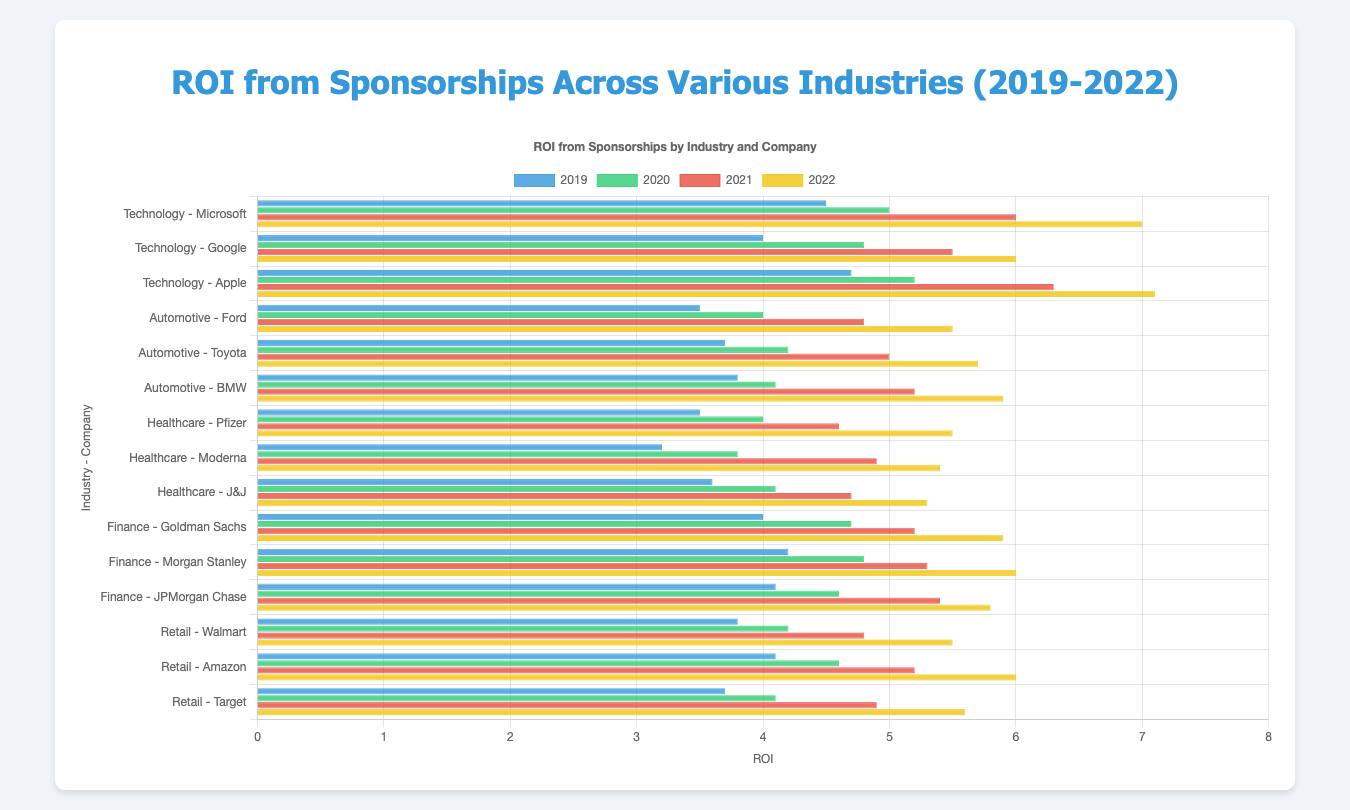What was the overall ROI trend for Technology companies from 2019 to 2022? Looking at the bars for Microsoft, Google, and Apple in the Technology sector, we observe that the heights of the bars increase consistently from 2019 to 2022 for all three companies. This indicates a general upward trend in ROI for Technology companies over these years.
Answer: Upward trend Which industry had the highest ROI in 2022, and which company contributed to it? By examining the lengths of the bars labeled '2022' across all industries, the Technology industry stands out with the highest bars. Specifically, Apple has the longest bar in 2022 within the Technology industry.
Answer: Technology, Apple What is the difference in ROI between Pfizer and Moderna in 2020? According to the bars in the Healthcare industry for 2020, Pfizer's ROI is 4.0 and Moderna's ROI is 3.8. The difference between their ROIs is 4.0 - 3.8 = 0.2.
Answer: 0.2 Which company's ROI showed the greatest improvement from 2019 to 2022 in the Automotive industry? For the Automotive industry, we compare the bars from 2019 to 2022 for Ford, Toyota, and BMW. BMW's ROI increased from 3.8 in 2019 to 5.9 in 2022, which is an increment of 2.1, the highest among the three.
Answer: BMW How did the average ROI of all Finance companies change from 2021 to 2022? To find the average ROI change, first calculate the average ROI in 2021 and 2022 for Goldman Sachs (5.2, 5.9), Morgan Stanley (5.3, 6.0), and JPMorgan Chase (5.4, 5.8). The average for 2021 is (5.2+5.3+5.4)/3 = 5.3 and for 2022 is (5.9+6.0+5.8)/3 = 5.9. The change is 5.9 - 5.3 = 0.6.
Answer: 0.6 In which year did Walmart show the highest ROI, and what was the value? Looking at the heights of the bars for Walmart, they increase from 2019 through 2022. The highest bar in 2022 shows an ROI of 5.5, which is the highest value for Walmart.
Answer: 2022, 5.5 Was the ROI for JPMorgan Chase higher in 2020 or 2021? Comparing the bars for JPMorgan Chase in the Finance industry for 2020 and 2021, we see that the bar for 2021 (5.4) is higher than that for 2020 (4.6).
Answer: 2021 Which year's data has the shortest bars for the Automotive industry overall? Observing the bars for Ford, Toyota, and BMW across all years within the Automotive industry, the shortest bars appear consistently in 2019.
Answer: 2019 How much did Apple's ROI increase from 2020 to 2021? Apple's ROI for 2020 is 5.2 and for 2021 is 6.3. The difference, which indicates the increase, is 6.3 - 5.2 = 1.1.
Answer: 1.1 